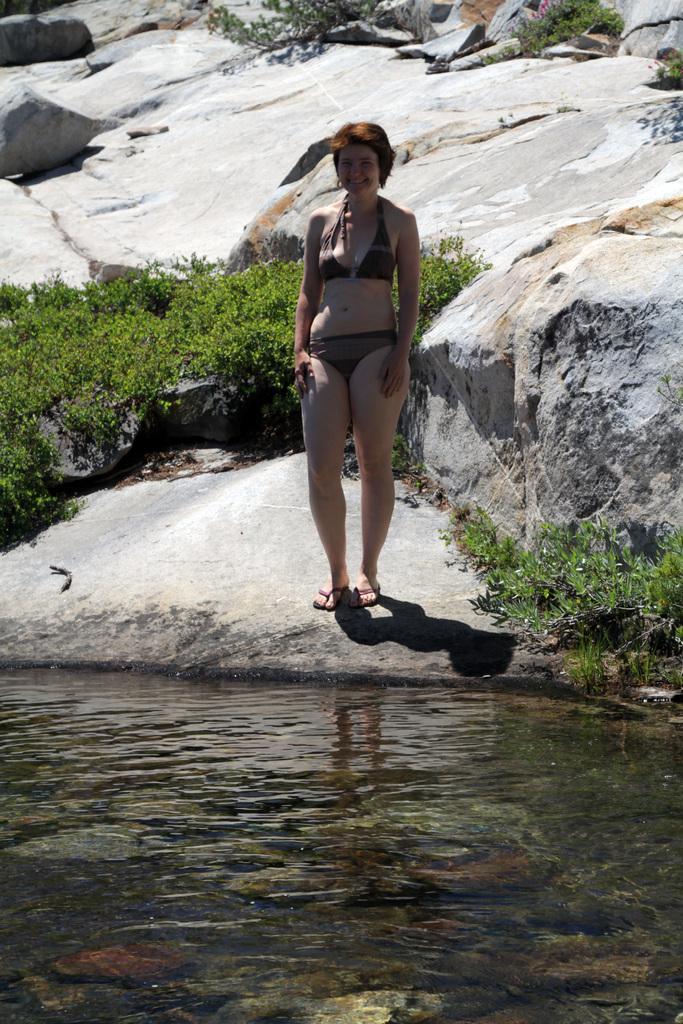Describe this image in one or two sentences. In this image there is a woman standing on the rock, in front of the woman there is water, behind the woman there are plants and rocks. 